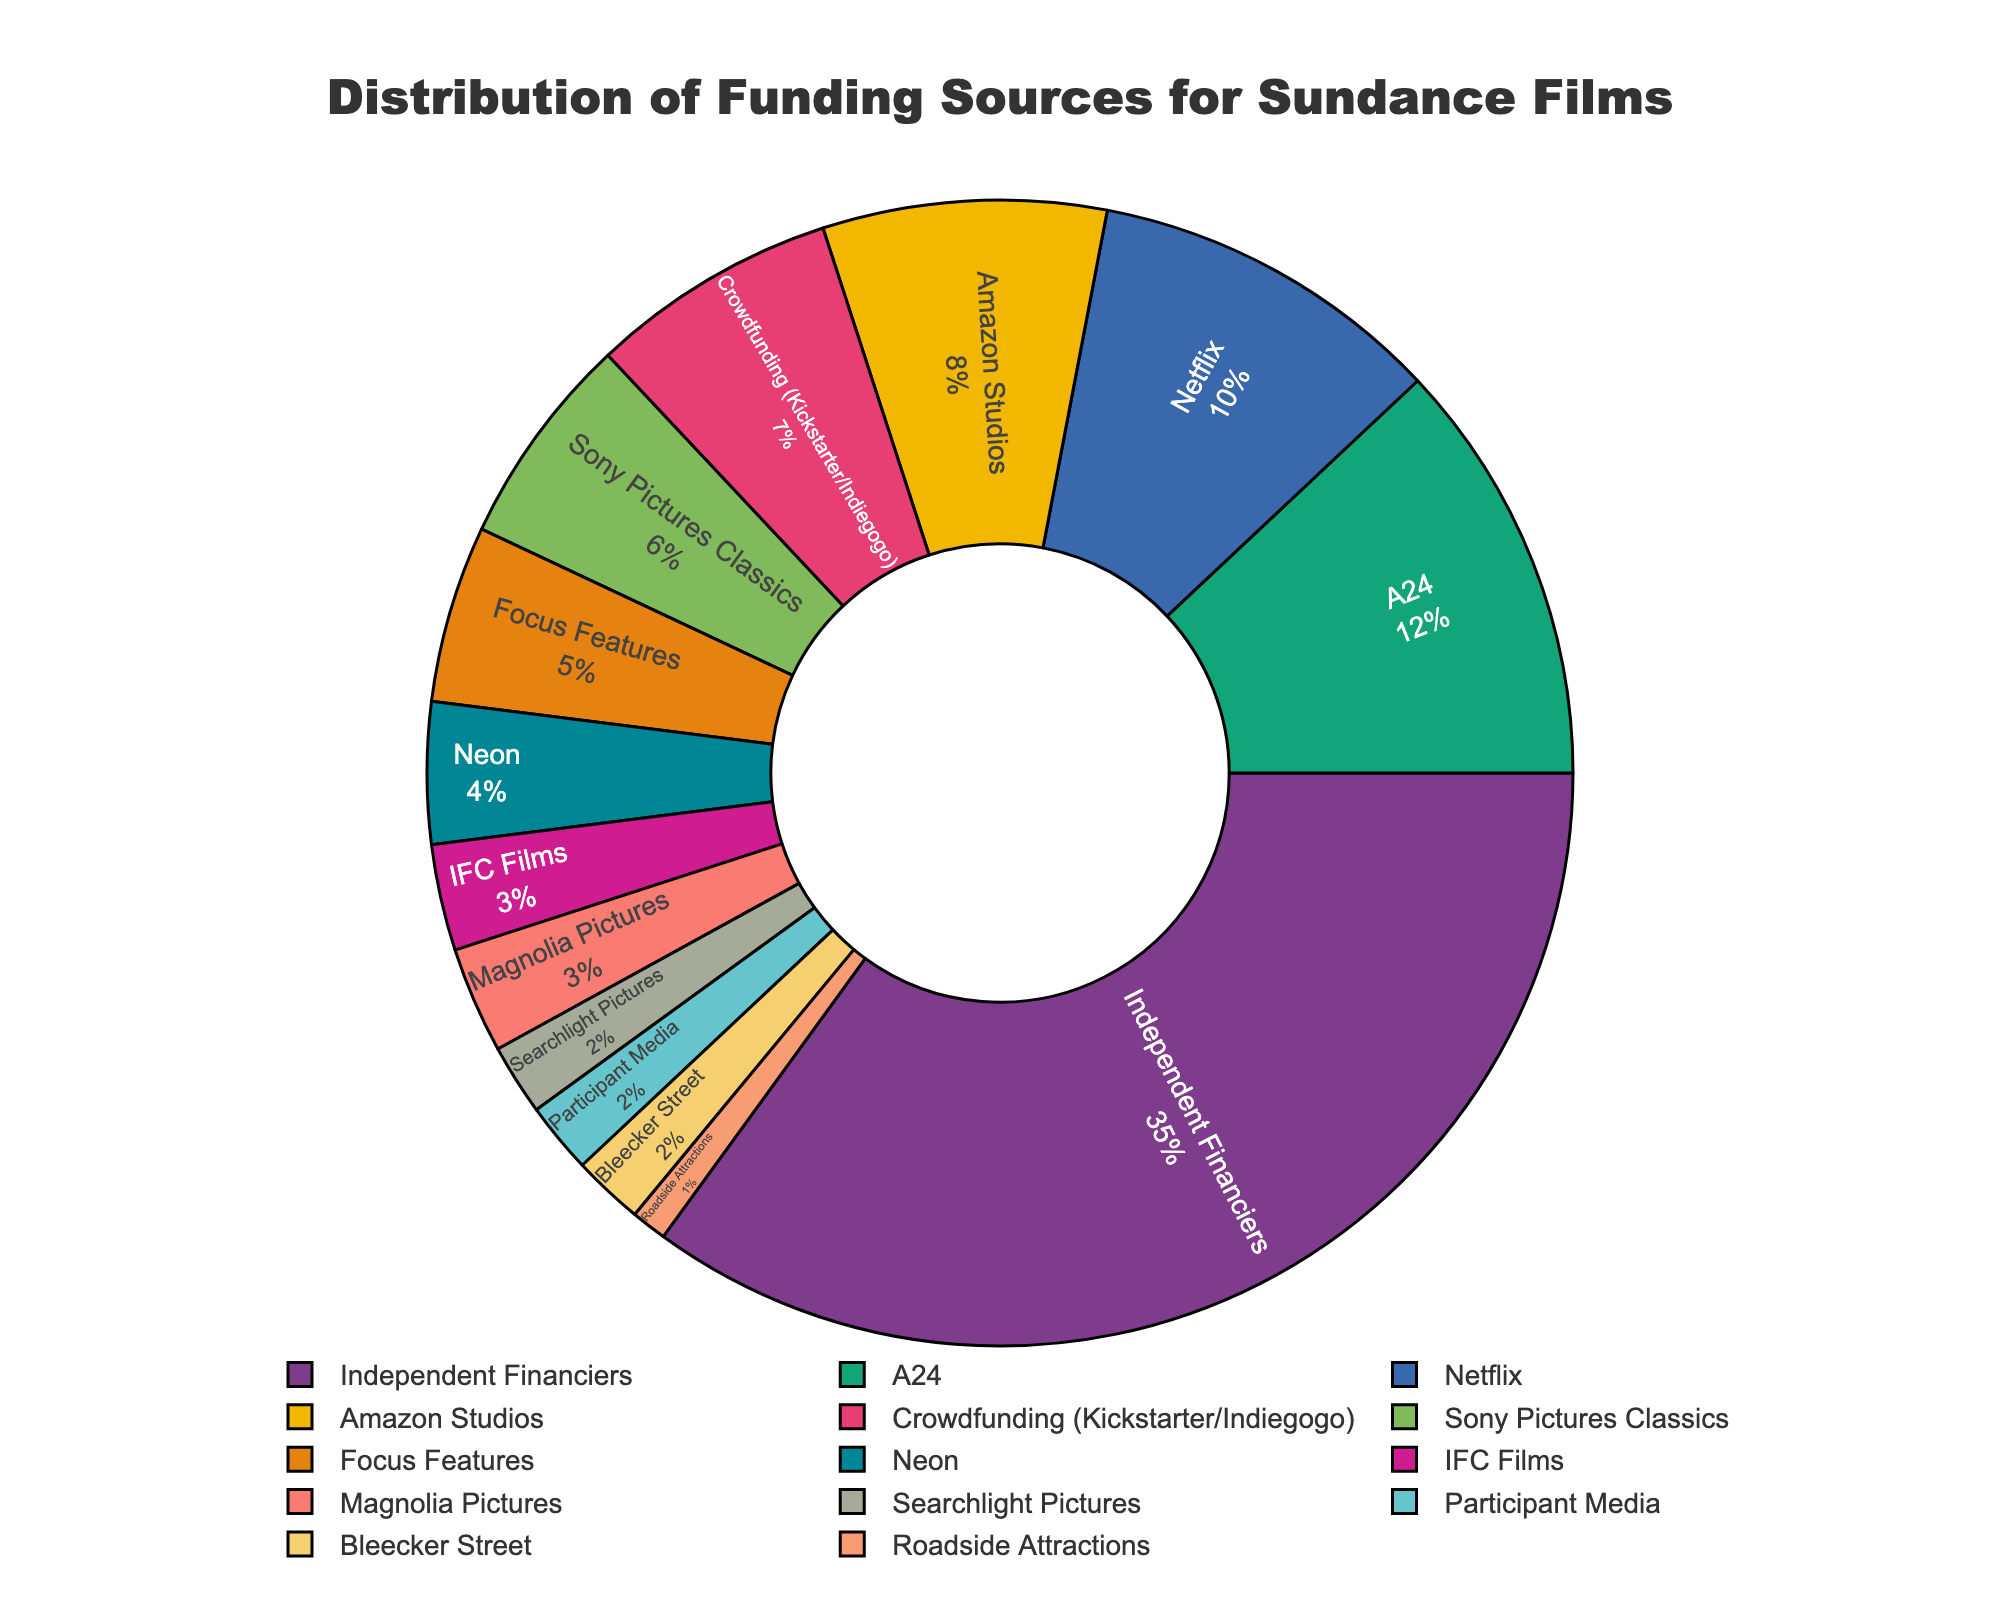What percentage of Sundance films are funded by Amazon Studios? To find the percentage of Sundance films funded by Amazon Studios, locate "Amazon Studios" in the pie chart and read the associated percentage.
Answer: 8% Which funding source has the smallest share, and what is its percentage? Locate the funding source with the smallest segment in the pie chart and read the associated percentage.
Answer: Roadside Attractions, 1% What is the combined percentage of films funded by Netflix and A24? Locate Netflix and A24 in the pie chart, read their respective percentages, and add them together: 10% (Netflix) + 12% (A24).
Answer: 22% How does the percentage of crowdfunded films compare to those funded by Independent Financiers? Locate both "Crowdfunding" and "Independent Financiers" in the pie chart, then compare their percentages: 7% (Crowdfunding) vs. 35% (Independent Financiers).
Answer: Crowdfunding is significantly less Are there any funding sources that have an equal share? If so, which ones? Locate segments that are equal in size in the pie chart. Note their percentages and names.
Answer: IFC Films and Magnolia Pictures, both 3% Which funding source contributes more: Sony Pictures Classics or Focus Features? Locate both "Sony Pictures Classics" and "Focus Features" in the pie chart, then compare their percentages: 6% (Sony Pictures Classics) and 5% (Focus Features).
Answer: Sony Pictures Classics What is the difference in percentage points between the highest and lowest funding sources? Identify the highest (Independent Financiers, 35%) and lowest (Roadside Attractions, 1%) percentages, then calculate their difference: 35% - 1%.
Answer: 34% How many funding sources have a percentage below 5%? Count the segments in the pie chart with associated percentages less than 5%.
Answer: 7 What is the collective percentage of films funded by all studio-backed sources (A24, Netflix, Amazon Studios, etc.)? Locate all the studio-backed sources in the pie chart, then sum their percentages: 12% (A24) + 10% (Netflix) + 8% (Amazon Studios) + 6% (Sony Pictures Classics) + 5% (Focus Features) + 4% (Neon) + 3% (IFC Films) + 3% (Magnolia Pictures) + 2% (Searchlight Pictures) + 2% (Participant Media) + 2% (Bleecker Street) + 1% (Roadside Attractions).
Answer: 48% What visual feature helps distinguish large funding sources from smaller ones in the pie chart? Look at the graphical representation of the pie chart to determine how large and small segments are visually different.
Answer: Size of the segments 